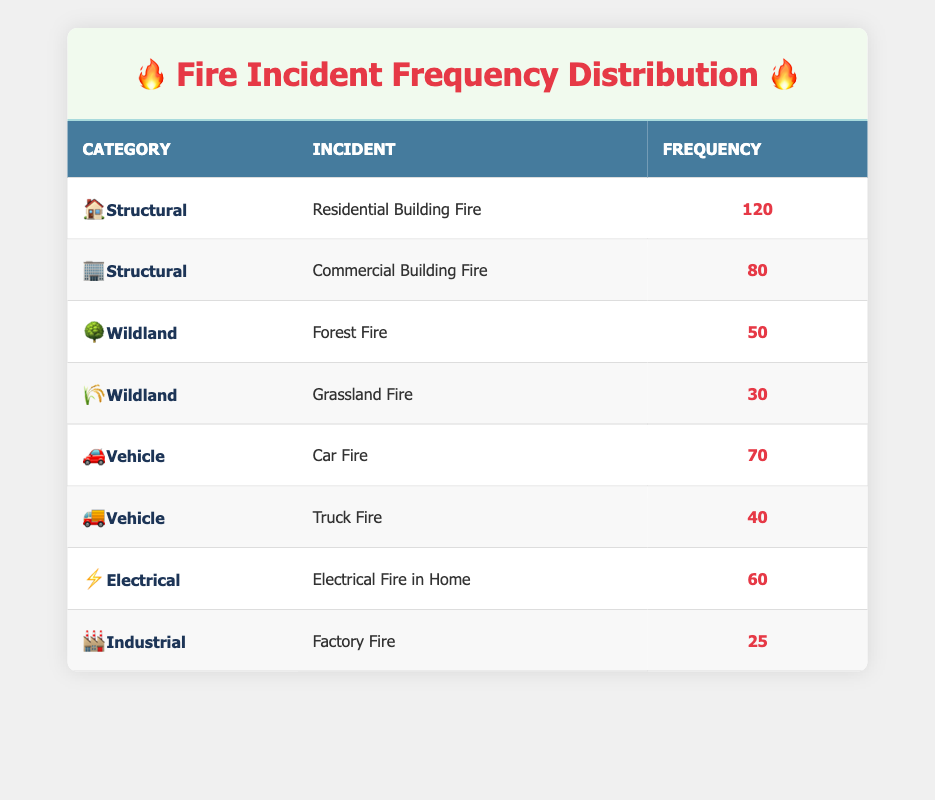What is the frequency of Residential Building Fires? The table lists "Residential Building Fire" under the "Structural" category with a frequency of 120.
Answer: 120 Which category has the highest total frequency? To find the total frequency for each category, we add the frequencies: Structural (120 + 80 = 200), Wildland (50 + 30 = 80), Vehicle (70 + 40 = 110), Electrical (60), and Industrial (25). The highest total frequency is for the Structural category with a total of 200.
Answer: Structural Is the frequency of Grassland Fires greater than that of Truck Fires? The frequency of Grassland Fires is 30, and the frequency of Truck Fires is 40. Since 30 is less than 40, the statement is false.
Answer: No What is the total frequency of fire incidents recorded in the Vehicle category? The frequencies in the Vehicle category are 70 for Car Fires and 40 for Truck Fires. Adding these gives 70 + 40 = 110, so the total frequency is 110.
Answer: 110 How many more incidents are reported in the Structural category than in the Wildland category? The total frequency for Structural incidents is 200 (120 + 80), and for Wildland incidents, it is 80 (50 + 30). The difference is 200 - 80 = 120, indicating that there are 120 more incidents reported in Structural than in Wildland.
Answer: 120 Are there any Electrical fires with a frequency greater than 50? The table shows that the frequency of "Electrical Fire in Home" is 60, which is greater than 50. Thus, the statement is true.
Answer: Yes What is the average frequency of all fire incidents listed in the table? To find the average, we first sum all the frequencies: 120 + 80 + 50 + 30 + 70 + 40 + 60 + 25 = 475. There are 8 incidents, so we divide the total frequency by the number of incidents: 475 / 8 = 59.375. Thus, the average frequency is 59.375.
Answer: 59.375 Overall, which type of fire incident has the lowest frequency? The incident with the lowest frequency is "Factory Fire" in the Industrial category, with a frequency of 25, as it is the minimum value in the frequency column across all incidents.
Answer: Factory Fire How many incidents are there in total for Structural and Electrical categories combined? The total for Structural is 200 and for Electrical is 60. Adding these gives 200 + 60 = 260, indicating that there are 260 incidents in these two categories combined.
Answer: 260 